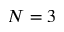Convert formula to latex. <formula><loc_0><loc_0><loc_500><loc_500>N = 3</formula> 